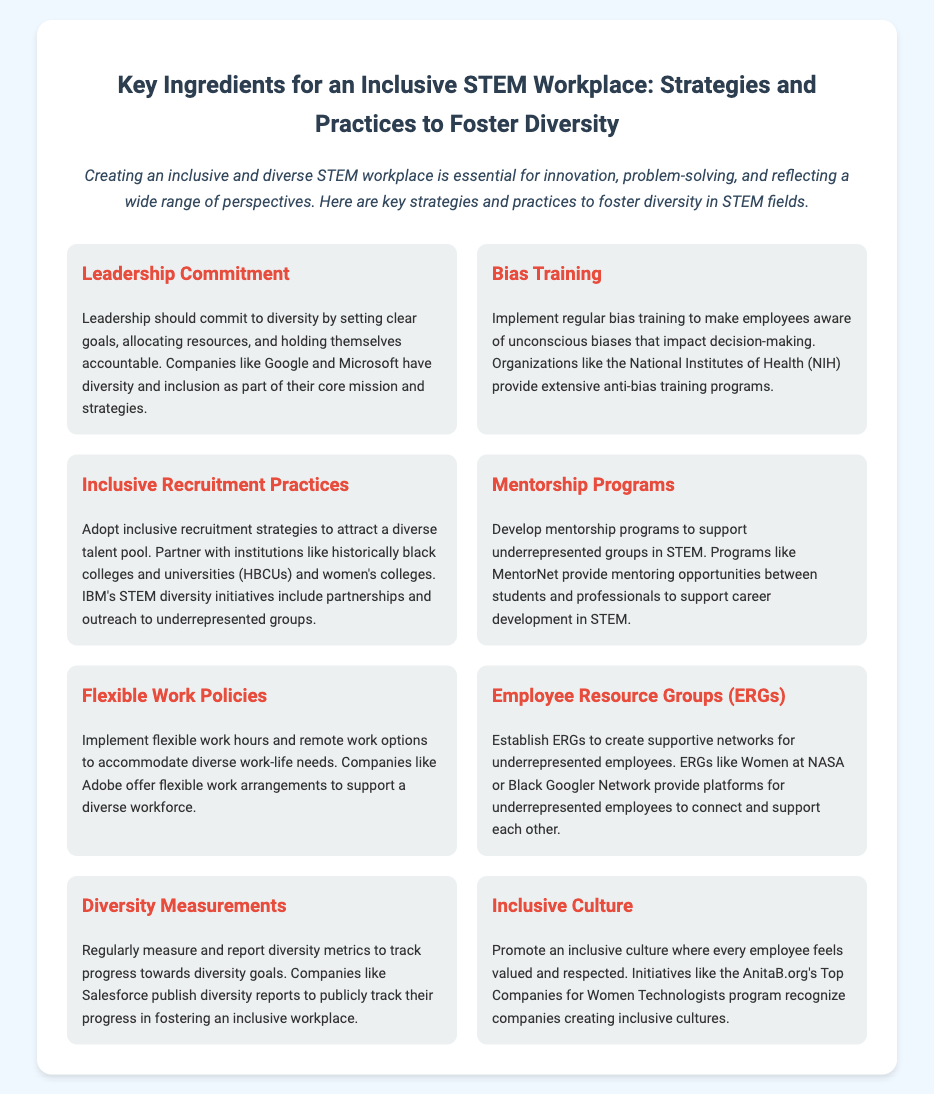What is the title of the document? The title of the document is mentioned at the top in a prominent font.
Answer: Key Ingredients for an Inclusive STEM Workplace: Strategies and Practices to Foster Diversity How many key ingredients are listed in the document? The document contains a specific number of key ingredients outlined in separate sections.
Answer: Eight Which company is mentioned as having part of their core mission focused on diversity? The text references specific companies known for their commitment to diversity in their strategies.
Answer: Google What type of training is suggested to raise awareness of unconscious biases? The document specifies the type of training that organizations are encouraged to implement.
Answer: Bias Training What does ERG stand for in the context of the document? The abbreviation ERG is defined within the document in relation to supportive networks for employees.
Answer: Employee Resource Groups Which program provides mentoring opportunities between students and professionals? The document highlights a specific program dedicated to facilitating mentoring in STEM fields.
Answer: MentorNet What is one of the flexible work policies mentioned? The document identifies a specific practice related to work flexibility that supports diversity.
Answer: Remote work options Name one recognized program aimed at creating inclusive cultures. The document references initiatives that evaluate and celebrate companies promoting inclusivity.
Answer: AnitaB.org's Top Companies for Women Technologists 